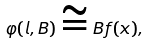Convert formula to latex. <formula><loc_0><loc_0><loc_500><loc_500>\varphi ( l , B ) \cong B f ( x ) ,</formula> 